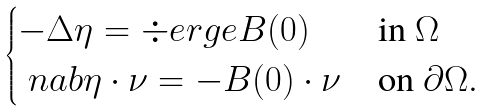<formula> <loc_0><loc_0><loc_500><loc_500>\begin{cases} - \Delta \eta = \div e r g e { B ( 0 ) } & \text {in } \Omega \\ \ n a b \eta \cdot \nu = - B ( 0 ) \cdot \nu & \text {on } \partial \Omega . \end{cases}</formula> 